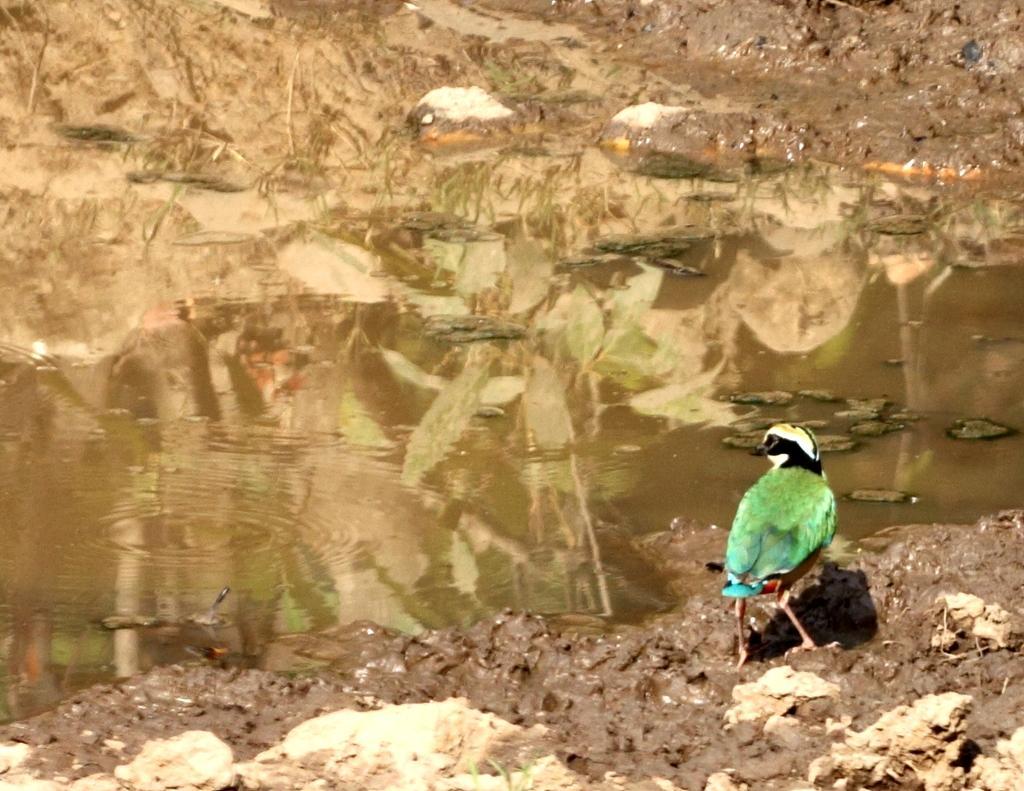How would you summarize this image in a sentence or two? In this picture I can observe a bird on the land. The bird is in green, black and white colors. I can observe some water. In the background there is some mud. 